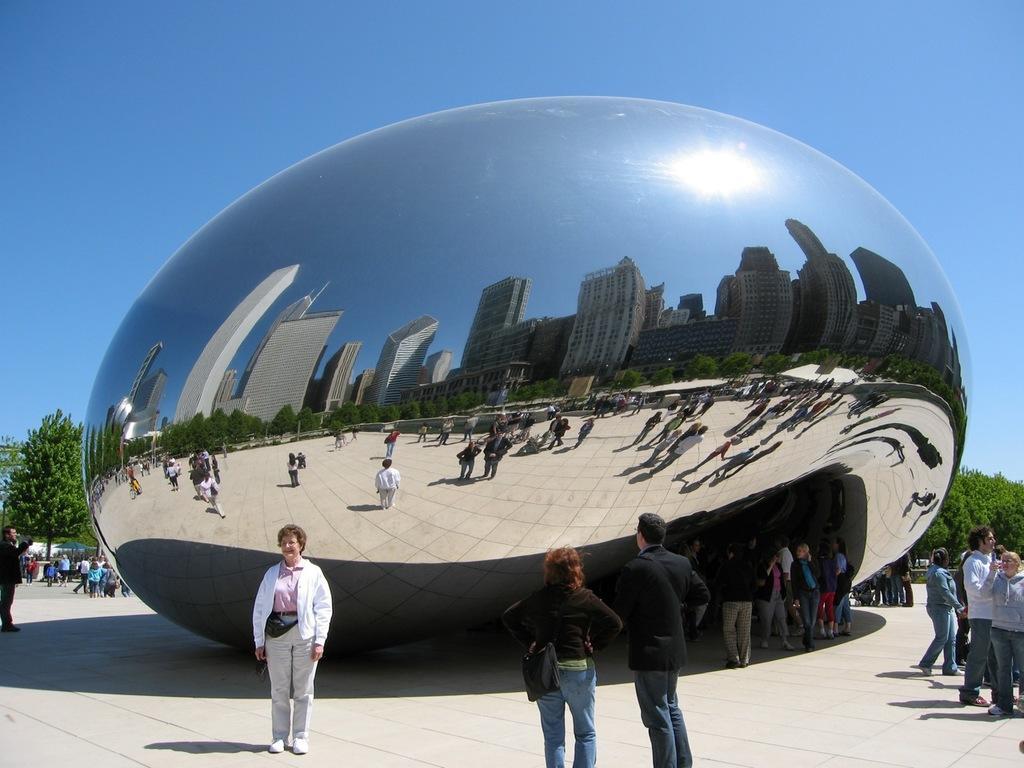Can you describe this image briefly? In the foreground of this image, there are persons standing on the floor. Behind them, there is a sculpture and in the reflection of that sculpture, there are trees, building, persons standing on the floor, sky and the sun. In the background, there are trees, persons on the floor and the sky. 